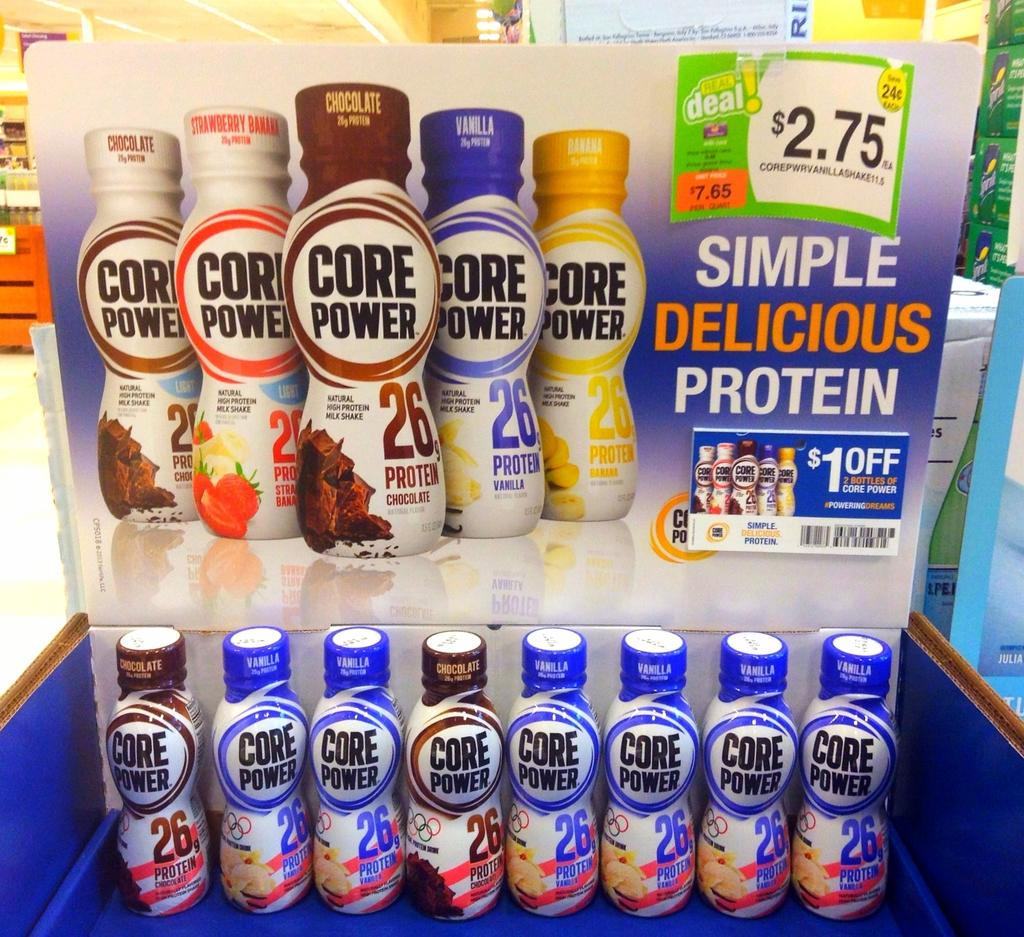What is the main feature in the foreground of the image? There are bottles arranged in a blue color rack in the foreground of the image. What is attached to the rack in the foreground? There is a banner associated with the rack. Can you describe the background of the image? There is a rack in the background of the image. What type of butter is being advertised on the banner in the image? There is no butter mentioned or advertised on the banner in the image. 